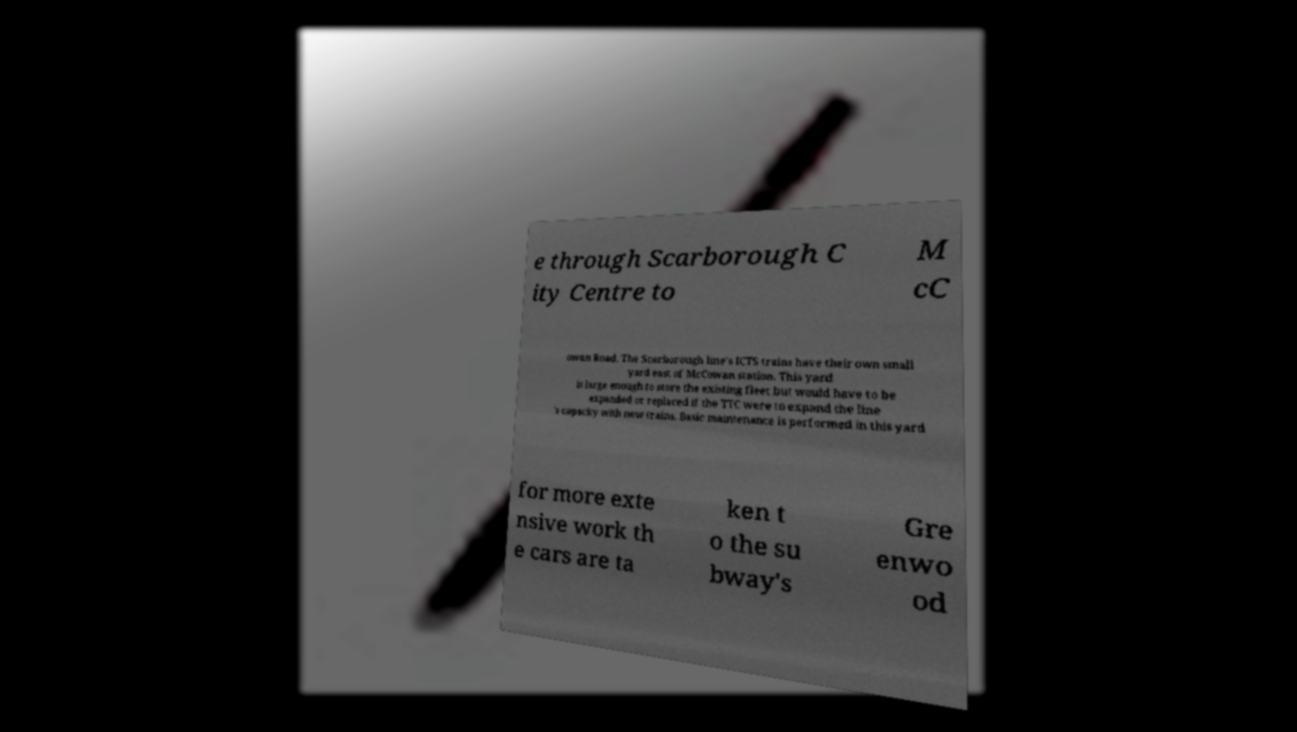Can you accurately transcribe the text from the provided image for me? e through Scarborough C ity Centre to M cC owan Road. The Scarborough line's ICTS trains have their own small yard east of McCowan station. This yard is large enough to store the existing fleet but would have to be expanded or replaced if the TTC were to expand the line 's capacity with new trains. Basic maintenance is performed in this yard for more exte nsive work th e cars are ta ken t o the su bway's Gre enwo od 